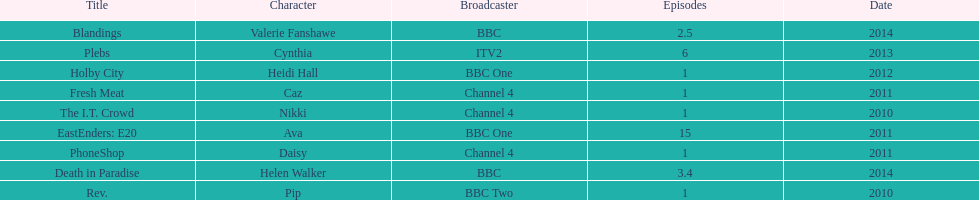What is the only role she played with broadcaster itv2? Cynthia. 